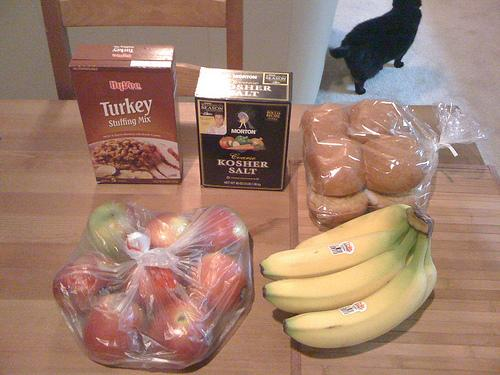Explain the key items in the image while focusing on the fruits and groceries. The image includes fruits like bananas, apples, and tomatoes, as well as groceries like salt, stuffing mix, and wheat buns, all on a wooden table. Summarize the main objects on the table in the image. Bananas, bag of apples, tomatoes, stuffing mix box, salt box, wheat buns, and a black cat are displayed on the table. Write a concise description of the items on the table in the image. The table features bananas, apples in a bag, tomatoes, a stuffing mix box, a salt box, wheat buns, and a black cat. Using simple terms, describe the main contents of the image. On the table, there are bananas, apples, tomatoes, stuffing mix, salt box, wheat buns, and a black cat. Mention the multiple objects present in the image, starting with fruits. Some fruits include bananas, apples, and tomatoes; other objects are a box of salt, box of stuffing mix, wheat buns, black cat, wooden table, and chair. Provide a short overview of what's visible in the image. The image shows various food items and a black cat on a wooden table with a wooden chair nearby. Describe the setting and objects in the image in a single sentence. On and around a wooden table and chair are items like bananas, apples, tomatoes, a box of stuffing mix, a box of salt, wheat buns, and a black cat. Provide a brief description of the primary objects in the image. There are bananas, apples, tomatoes, a box of salt, a box of stuffing mix, wheat buns, and a black cat on a wooden table with a wooden chair. List the main objects on the table in the image along with their characteristics. Bananas (yellow), apples (in a plastic bag), tomatoes (in a cover), box of stuffing mix (brown), box of salt (large), wheat buns (in a plastic bag), and a cat (black). Describe the main elements in the image using simple adjectives. Yellow bananas, red apples, red tomatoes, white stuffing mix box, blue salt box, brown wheat buns, and a fluffy black cat are on a wooden table. 